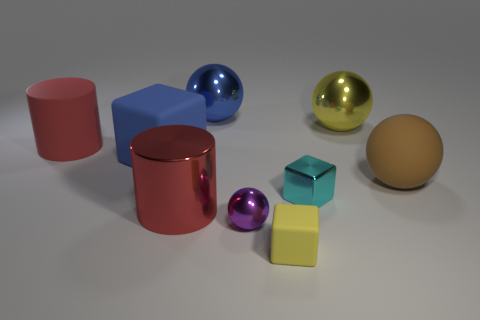There is a yellow thing that is the same material as the big blue sphere; what shape is it? The yellow object that shares the same glossy, smooth material with the large blue sphere is also a sphere, showcasing a smooth spherical shape characterized by its three-dimensional symmetry. 